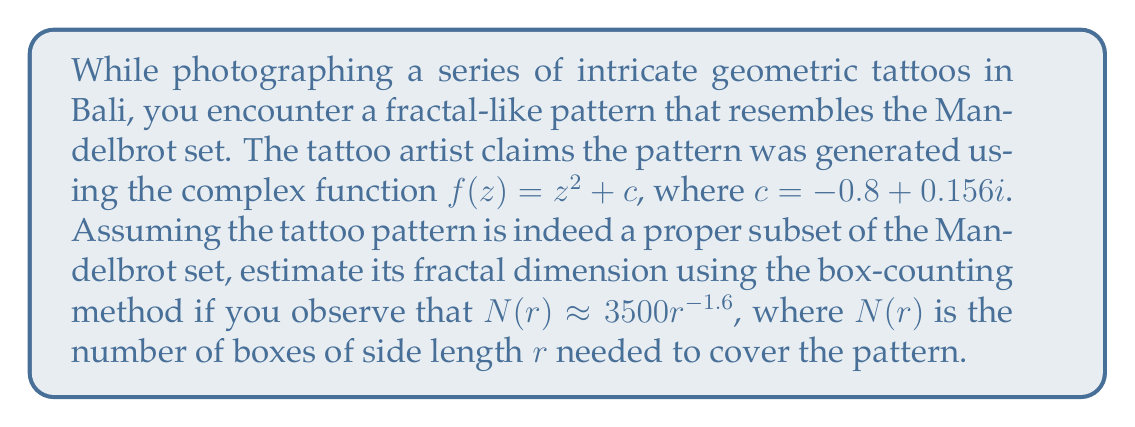Give your solution to this math problem. To determine the fractal dimension using the box-counting method, we follow these steps:

1) The general form of the box-counting relationship is:

   $$N(r) \approx kr^{-D}$$

   where $k$ is a constant, $r$ is the box side length, and $D$ is the fractal dimension.

2) In this case, we're given:

   $$N(r) \approx 3500r^{-1.6}$$

3) Comparing this to the general form, we can see that:

   $k = 3500$
   $D = 1.6$

4) The fractal dimension $D$ is the exponent in this relationship, so the estimated fractal dimension of the tattoo pattern is 1.6.

5) This value makes sense for a subset of the Mandelbrot set, as the Mandelbrot set itself has a fractal dimension of approximately 2, and any subset would have a dimension less than or equal to this.

6) The fact that the dimension is non-integer confirms the fractal nature of the pattern.
Answer: $1.6$ 